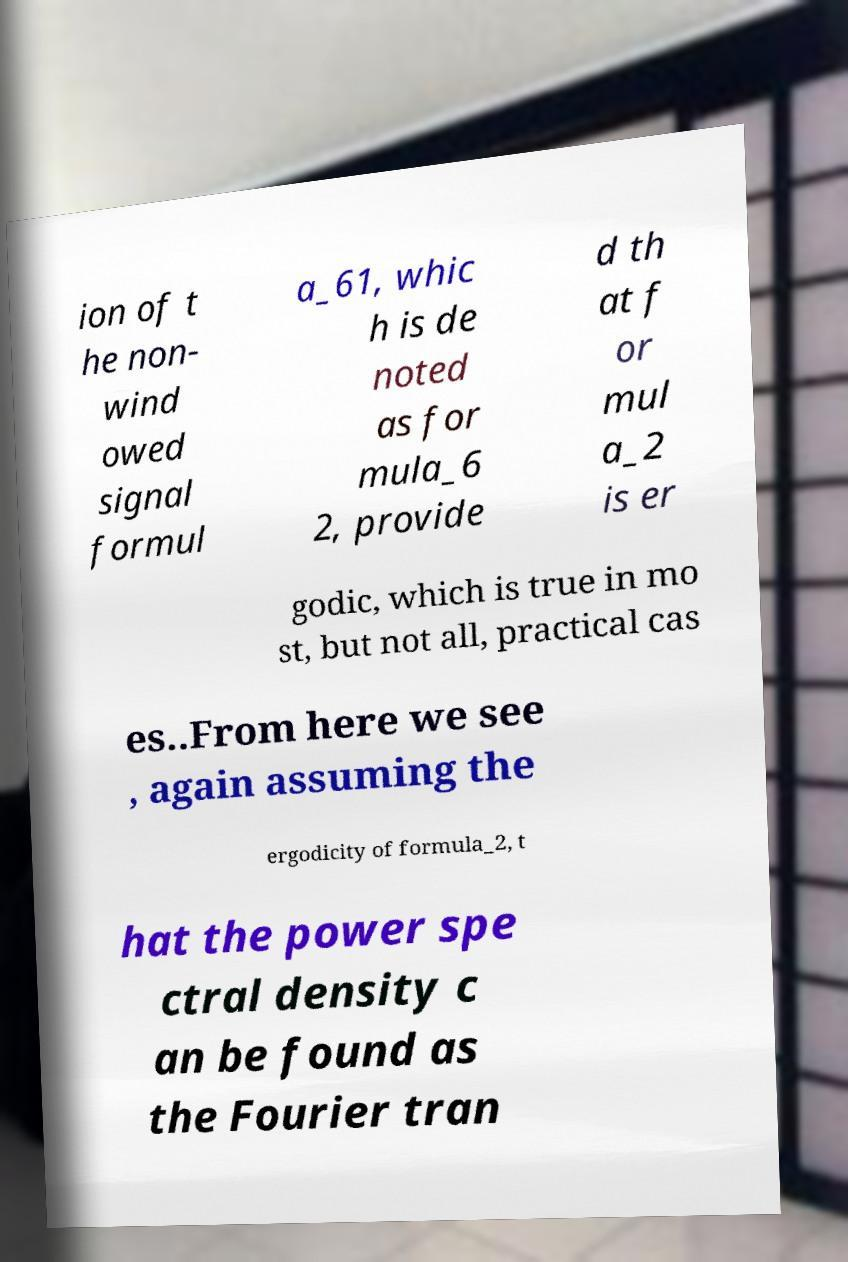Can you read and provide the text displayed in the image?This photo seems to have some interesting text. Can you extract and type it out for me? ion of t he non- wind owed signal formul a_61, whic h is de noted as for mula_6 2, provide d th at f or mul a_2 is er godic, which is true in mo st, but not all, practical cas es..From here we see , again assuming the ergodicity of formula_2, t hat the power spe ctral density c an be found as the Fourier tran 